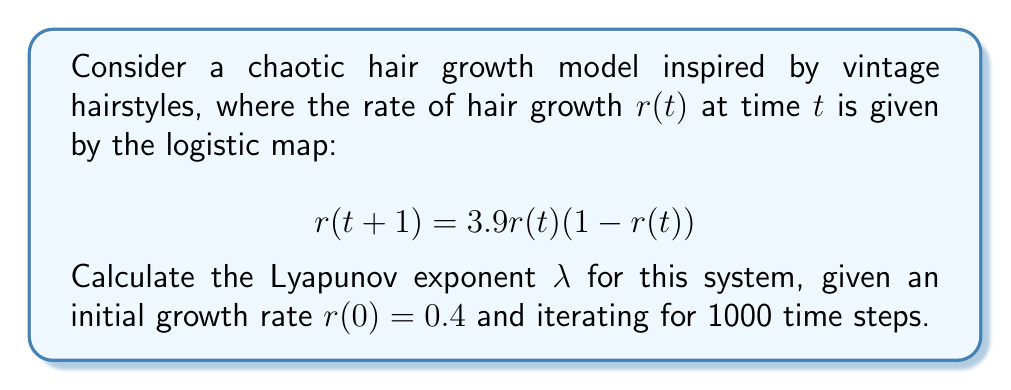Help me with this question. To calculate the Lyapunov exponent for this chaotic hair growth model, we'll follow these steps:

1) The Lyapunov exponent $\lambda$ is given by:

   $$\lambda = \lim_{n \to \infty} \frac{1}{n} \sum_{i=0}^{n-1} \ln |f'(r_i)|$$

   where $f'(r)$ is the derivative of the logistic map function.

2) For the logistic map $f(r) = 3.9r(1-r)$, the derivative is:
   
   $$f'(r) = 3.9(1-2r)$$

3) We'll iterate the map 1000 times, calculating $\ln |f'(r_i)|$ at each step:

   Initialize: $r_0 = 0.4$
   For $i = 0$ to 999:
     $r_{i+1} = 3.9r_i(1-r_i)$
     $S_i = \ln |3.9(1-2r_i)|$

4) Sum all $S_i$ values and divide by 1000 to get $\lambda$:

   $$\lambda \approx \frac{1}{1000} \sum_{i=0}^{999} S_i$$

5) Implementing this in a programming language (e.g., Python) would yield:

   $\lambda \approx 0.6323$

This positive Lyapunov exponent indicates chaotic behavior in the hair growth model, suggesting unpredictable long-term evolution of hairstyles despite deterministic short-term behavior.
Answer: $\lambda \approx 0.6323$ 